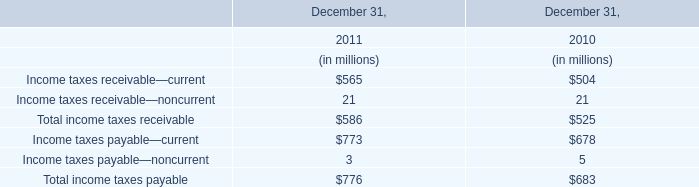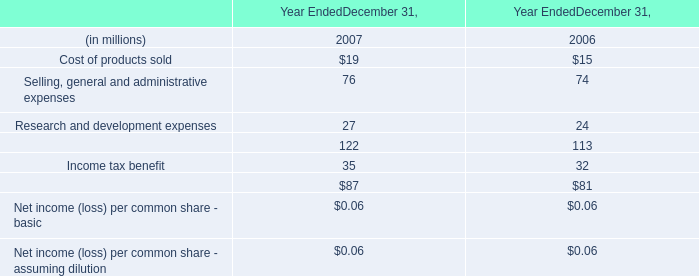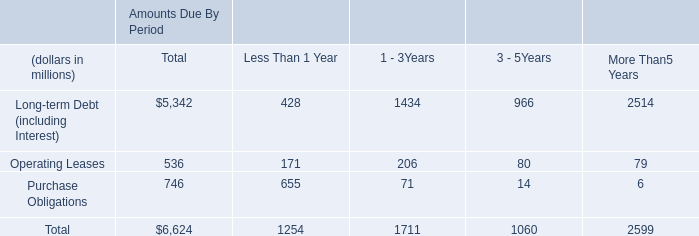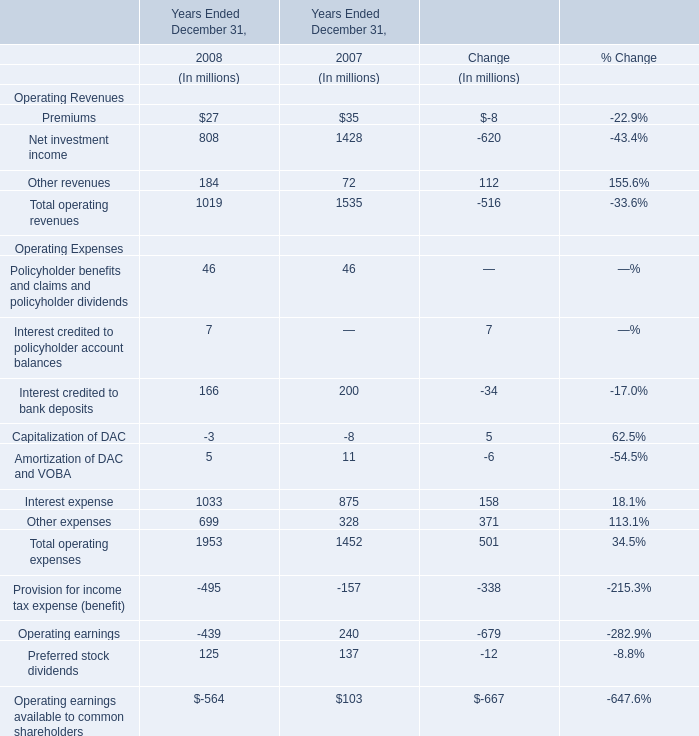What is the sum of Total operating revenues in 2007 and Total income taxes receivable in 2010? (in million) 
Computations: (1535 + 525)
Answer: 2060.0. 